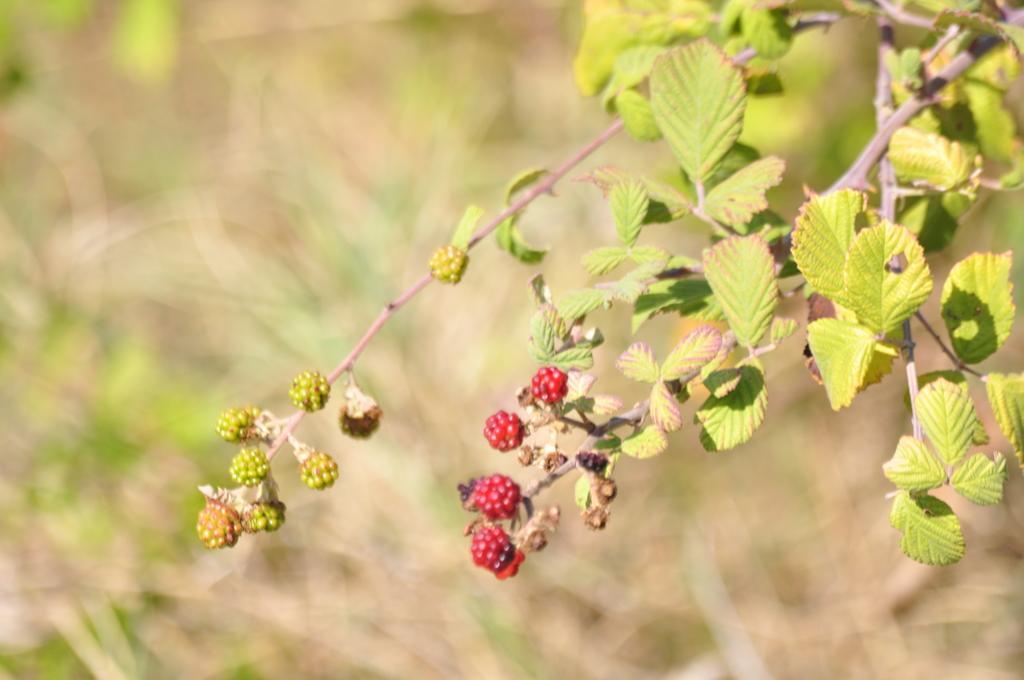Describe this image in one or two sentences. There are berries to a plant and the background is blurred. 